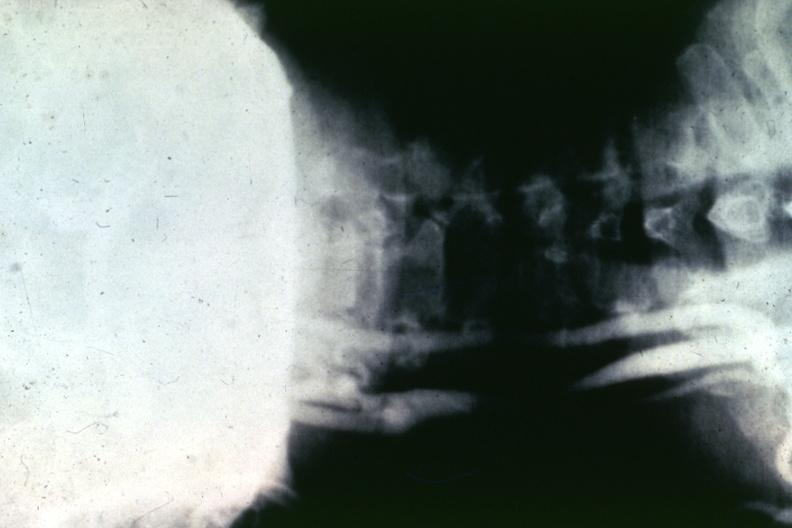s muscle atrophy present?
Answer the question using a single word or phrase. No 